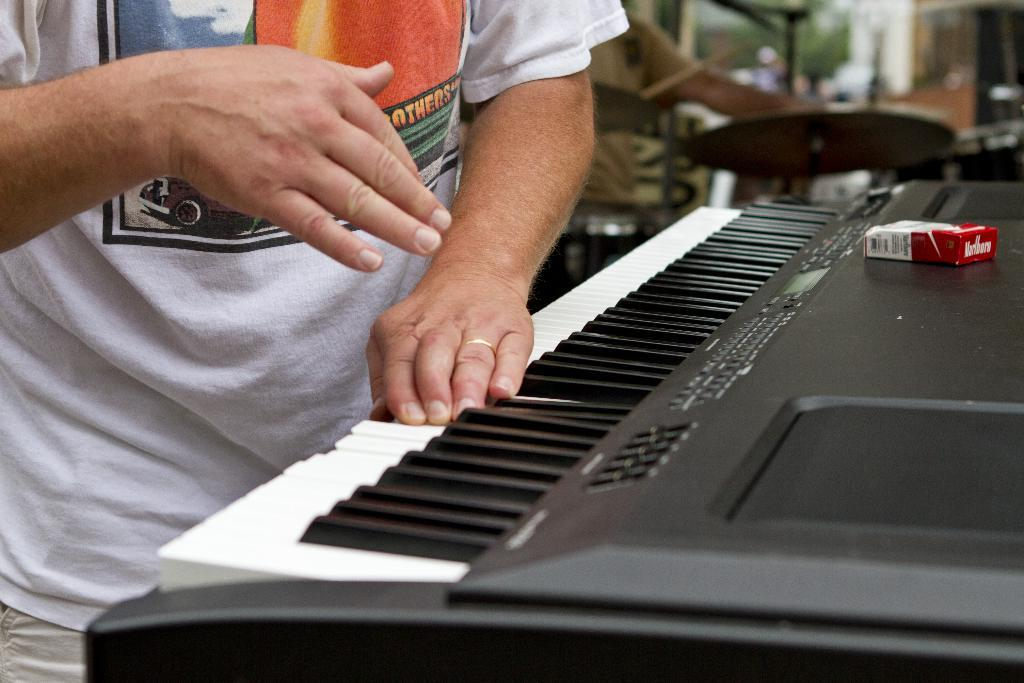What is the man in the image doing? The man is playing a musical keyboard. What other musical instruments can be seen in the image? There are musical drums in the image. How many friends does the actor have in the image? There is no actor present in the image, and therefore no friends to count. 